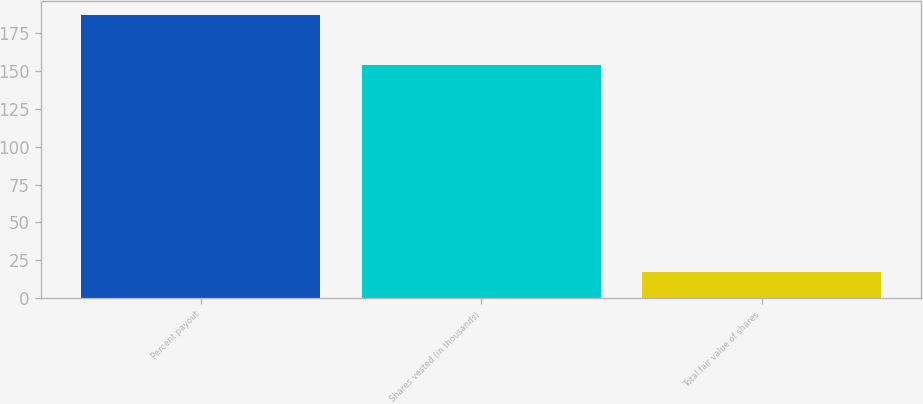Convert chart. <chart><loc_0><loc_0><loc_500><loc_500><bar_chart><fcel>Percent payout<fcel>Shares vested (in thousands)<fcel>Total fair value of shares<nl><fcel>187<fcel>154<fcel>17.2<nl></chart> 